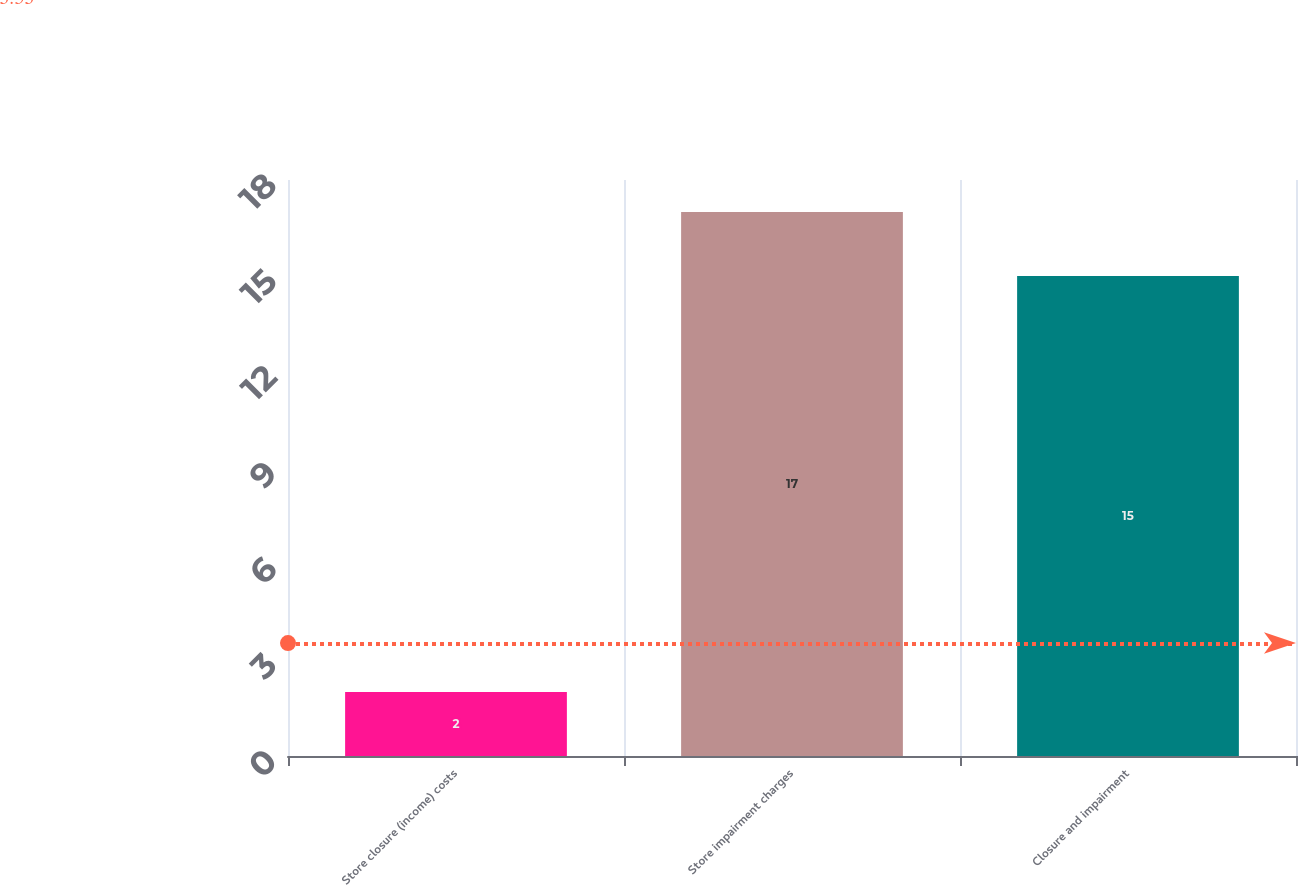Convert chart. <chart><loc_0><loc_0><loc_500><loc_500><bar_chart><fcel>Store closure (income) costs<fcel>Store impairment charges<fcel>Closure and impairment<nl><fcel>2<fcel>17<fcel>15<nl></chart> 